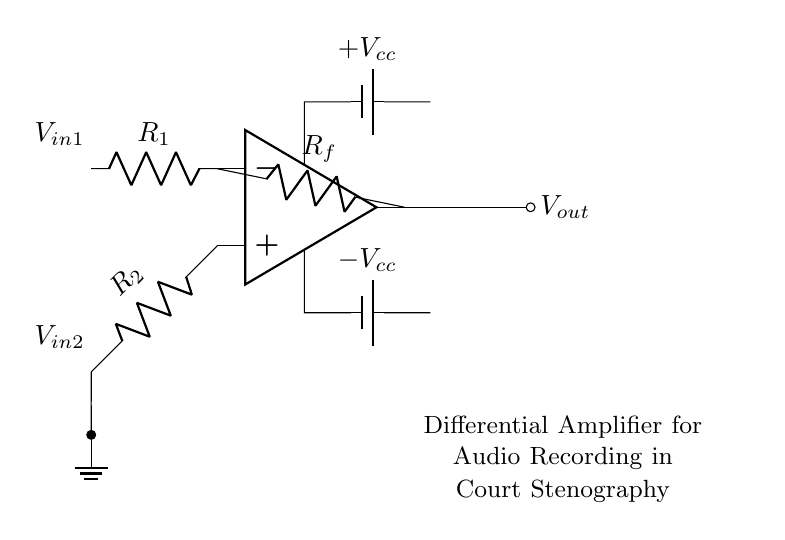What type of amplifier is shown in the circuit? The circuit is a differential amplifier, characterized by its ability to amplify the difference between two input voltages. This is indicated by the labeling of the inputs on the operational amplifier terminals.
Answer: Differential amplifier What are the input resistors in the circuit? The circuit contains two input resistors labeled R1 and R2, which are connected to the inverting and non-inverting terminals of the operational amplifier, respectively.
Answer: R1 and R2 What is the purpose of the feedback resistor? The feedback resistor, labeled Rf, connects from the output of the amplifier back to the inverting input, allowing for control of the gain and stability of the amplifier circuit.
Answer: Control gain What are the supply voltages used in this circuit? The supply voltages are labeled as +Vcc and -Vcc, which provide the necessary power for the operational amplifier to function. This helps maintain the proper voltage levels for amplification.
Answer: +Vcc and -Vcc How many input signals does this differential amplifier take? The differential amplifier accepts two input signals, V_in1 and V_in2, which are represented in the diagram; this allows the amplifier to respond to the difference between these inputs.
Answer: Two signals Why is one input connected to ground? Grounding one input, specifically V_in2, provides a reference point for the amplifier to measure the voltage difference from V_in1; it is essential for differential operation and helps achieve accurate amplification.
Answer: Reference point 